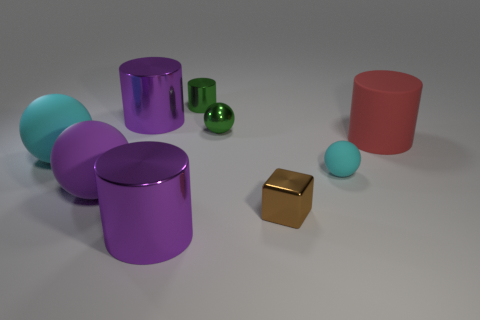There is a cylinder that is both in front of the green metal cylinder and behind the green shiny sphere; what material is it?
Keep it short and to the point. Metal. Is the number of big cylinders behind the large cyan rubber ball greater than the number of big red rubber cylinders that are behind the red matte cylinder?
Give a very brief answer. Yes. There is a green cylinder that is the same size as the green sphere; what is its material?
Your response must be concise. Metal. What size is the other cyan thing that is the same material as the small cyan object?
Ensure brevity in your answer.  Large. How many big metal objects are behind the large rubber ball in front of the tiny sphere that is to the right of the tiny brown metal thing?
Provide a short and direct response. 1. What is the material of the small green thing that is the same shape as the red thing?
Ensure brevity in your answer.  Metal. There is a large object in front of the tiny brown shiny cube; what color is it?
Make the answer very short. Purple. Are the red cylinder and the cyan ball that is left of the tiny brown cube made of the same material?
Your answer should be compact. Yes. What is the material of the big cyan ball?
Give a very brief answer. Rubber. What is the shape of the red thing that is the same material as the purple ball?
Provide a succinct answer. Cylinder. 